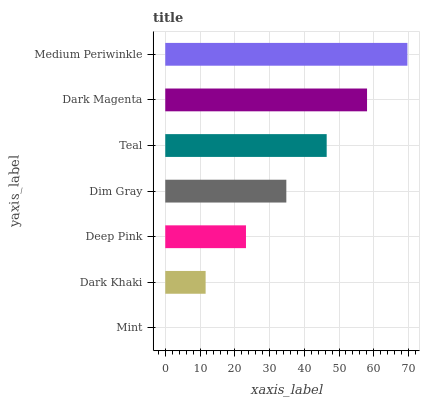Is Mint the minimum?
Answer yes or no. Yes. Is Medium Periwinkle the maximum?
Answer yes or no. Yes. Is Dark Khaki the minimum?
Answer yes or no. No. Is Dark Khaki the maximum?
Answer yes or no. No. Is Dark Khaki greater than Mint?
Answer yes or no. Yes. Is Mint less than Dark Khaki?
Answer yes or no. Yes. Is Mint greater than Dark Khaki?
Answer yes or no. No. Is Dark Khaki less than Mint?
Answer yes or no. No. Is Dim Gray the high median?
Answer yes or no. Yes. Is Dim Gray the low median?
Answer yes or no. Yes. Is Dark Magenta the high median?
Answer yes or no. No. Is Deep Pink the low median?
Answer yes or no. No. 